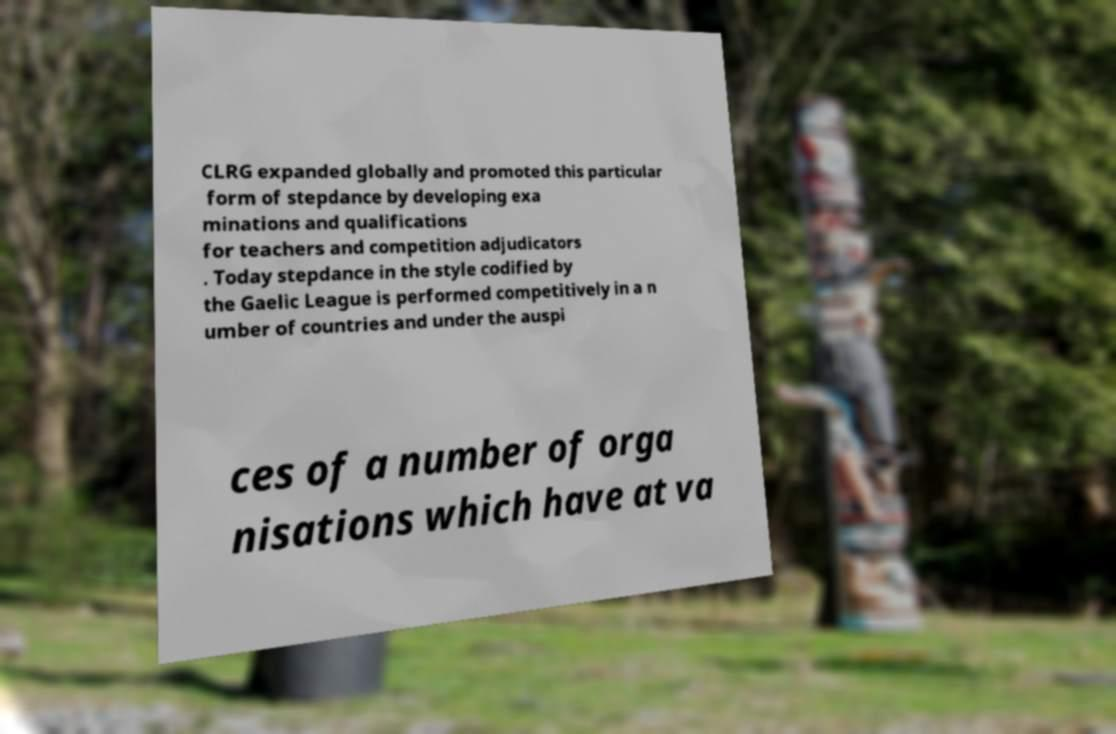Could you extract and type out the text from this image? CLRG expanded globally and promoted this particular form of stepdance by developing exa minations and qualifications for teachers and competition adjudicators . Today stepdance in the style codified by the Gaelic League is performed competitively in a n umber of countries and under the auspi ces of a number of orga nisations which have at va 